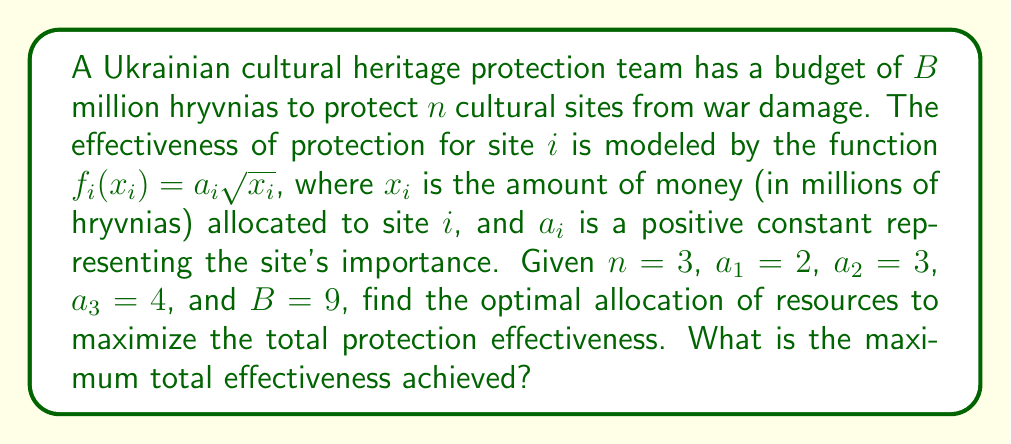Could you help me with this problem? To solve this optimization problem, we'll use the method of Lagrange multipliers:

1) Our objective function is the total effectiveness:
   $$f(x_1, x_2, x_3) = 2\sqrt{x_1} + 3\sqrt{x_2} + 4\sqrt{x_3}$$

2) The constraint is the total budget:
   $$g(x_1, x_2, x_3) = x_1 + x_2 + x_3 - 9 = 0$$

3) Form the Lagrangian:
   $$L(x_1, x_2, x_3, \lambda) = 2\sqrt{x_1} + 3\sqrt{x_2} + 4\sqrt{x_3} - \lambda(x_1 + x_2 + x_3 - 9)$$

4) Take partial derivatives and set them to zero:
   $$\frac{\partial L}{\partial x_1} = \frac{1}{\sqrt{x_1}} - \lambda = 0$$
   $$\frac{\partial L}{\partial x_2} = \frac{3}{2\sqrt{x_2}} - \lambda = 0$$
   $$\frac{\partial L}{\partial x_3} = \frac{2}{\sqrt{x_3}} - \lambda = 0$$
   $$\frac{\partial L}{\partial \lambda} = x_1 + x_2 + x_3 - 9 = 0$$

5) From these equations, we can derive:
   $$x_1 = \frac{1}{\lambda^2}, x_2 = \frac{9}{4\lambda^2}, x_3 = \frac{4}{\lambda^2}$$

6) Substituting into the constraint equation:
   $$\frac{1}{\lambda^2} + \frac{9}{4\lambda^2} + \frac{4}{\lambda^2} = 9$$
   $$\frac{29}{4\lambda^2} = 9$$
   $$\lambda^2 = \frac{29}{36}$$
   $$\lambda = \frac{\sqrt{29}}{6}$$

7) Now we can find the optimal allocations:
   $$x_1 = \frac{36}{29}, x_2 = \frac{81}{29}, x_3 = \frac{144}{29}$$

8) The maximum total effectiveness is:
   $$f(x_1, x_2, x_3) = 2\sqrt{\frac{36}{29}} + 3\sqrt{\frac{81}{29}} + 4\sqrt{\frac{144}{29}} = 2\cdot\frac{6}{\sqrt{29}} + 3\cdot\frac{9}{\sqrt{29}} + 4\cdot\frac{12}{\sqrt{29}} = \frac{102}{\sqrt{29}}$$
Answer: $\frac{102}{\sqrt{29}}$ (approximately 18.94) 